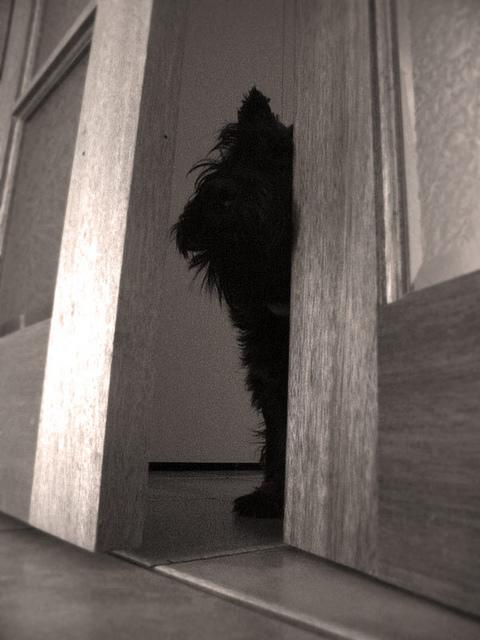Is the dog inside or outside?
Short answer required. Inside. What is behind the door?
Short answer required. Dog. Which way is the dog's left ear pointing?
Write a very short answer. Up. Are there windows in the door?
Give a very brief answer. Yes. 